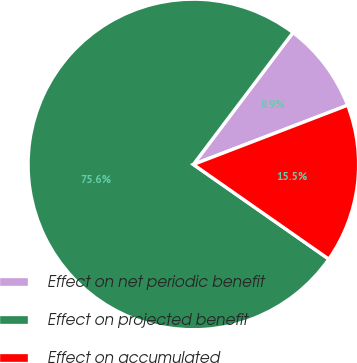Convert chart. <chart><loc_0><loc_0><loc_500><loc_500><pie_chart><fcel>Effect on net periodic benefit<fcel>Effect on projected benefit<fcel>Effect on accumulated<nl><fcel>8.87%<fcel>75.58%<fcel>15.54%<nl></chart> 